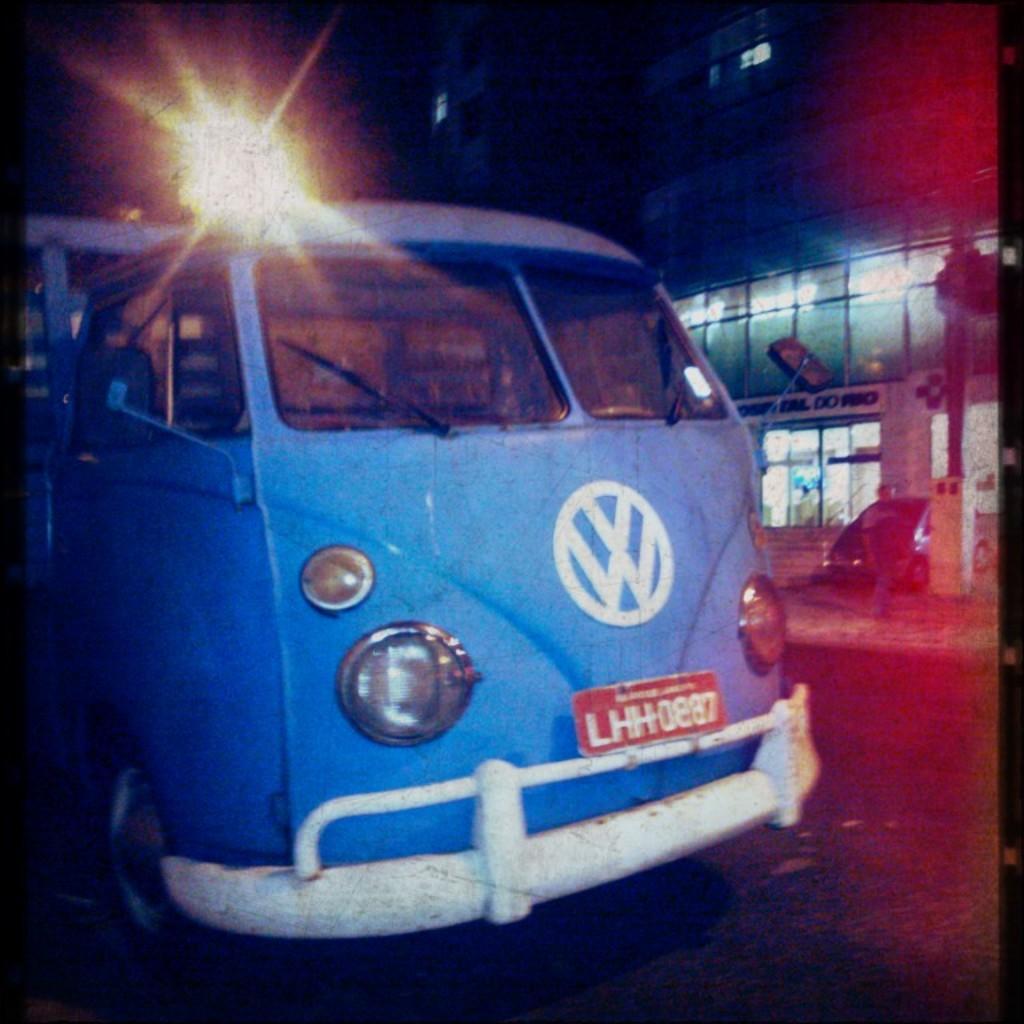Can you describe this image briefly? In the foreground of this picture, there is a vehicle moving on the road. In the background, there is a person, vehicle, pole, building and a light. 